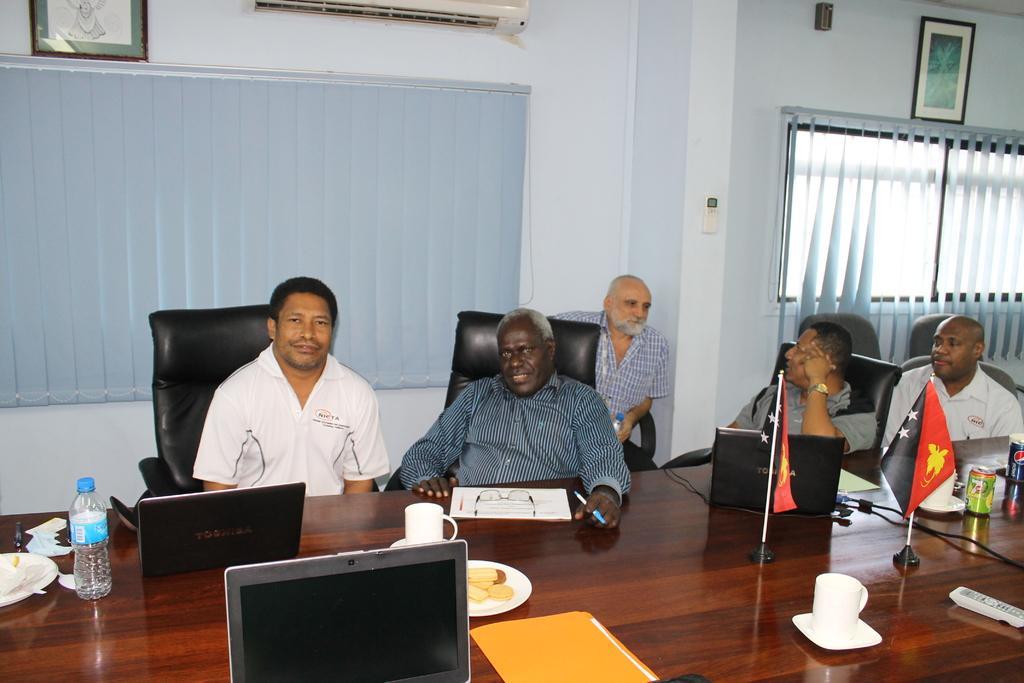Please provide a concise description of this image. In this image, we can see five people are sitting on a chair. At the bottom, we can see a wooden table, so many things, items are placed on it. Background we can see a wall, glass windows, shades. Top of the image, we can see photo frames, air conditioner. Here we can see few people are holding some objects. 